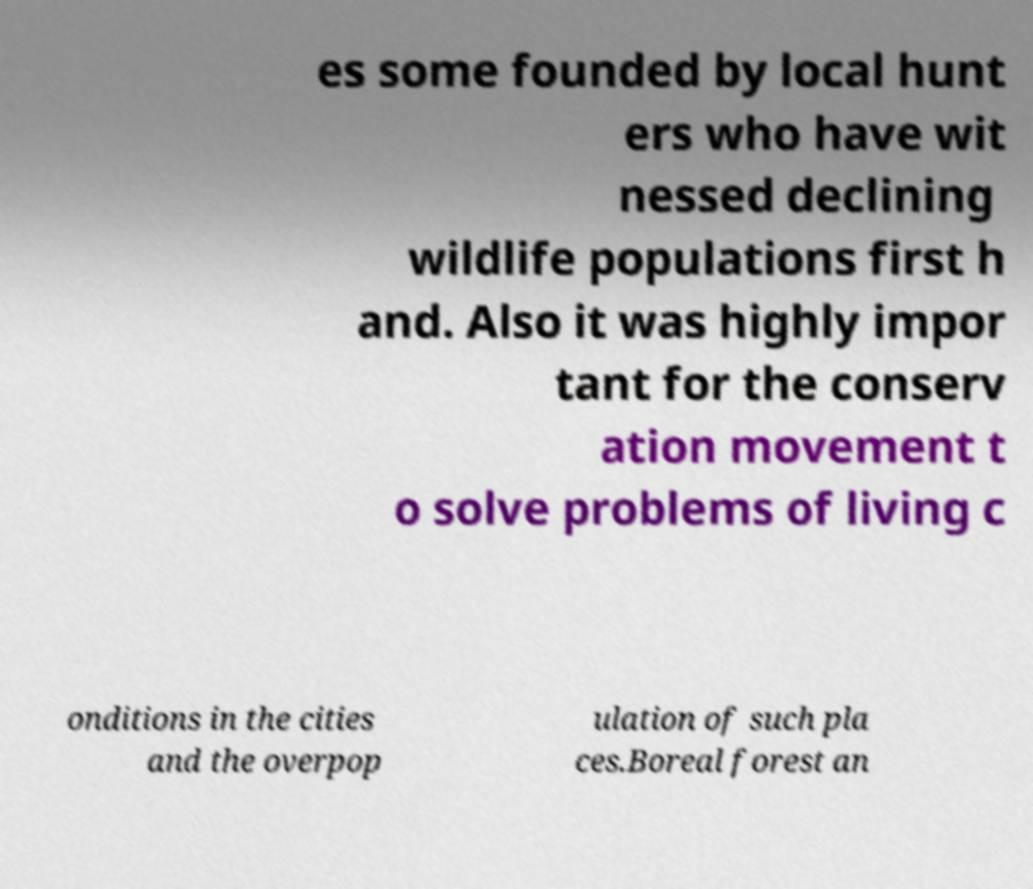Could you extract and type out the text from this image? es some founded by local hunt ers who have wit nessed declining wildlife populations first h and. Also it was highly impor tant for the conserv ation movement t o solve problems of living c onditions in the cities and the overpop ulation of such pla ces.Boreal forest an 